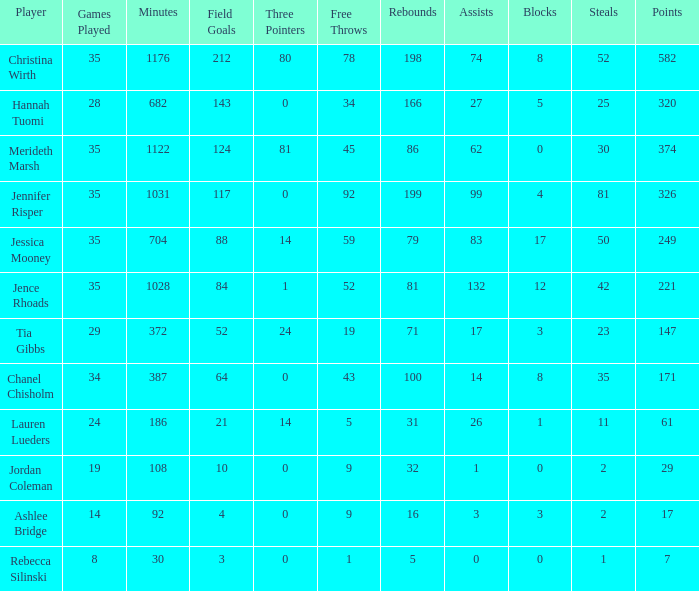What is the lowest number of games played by the player with 50 steals? 35.0. 